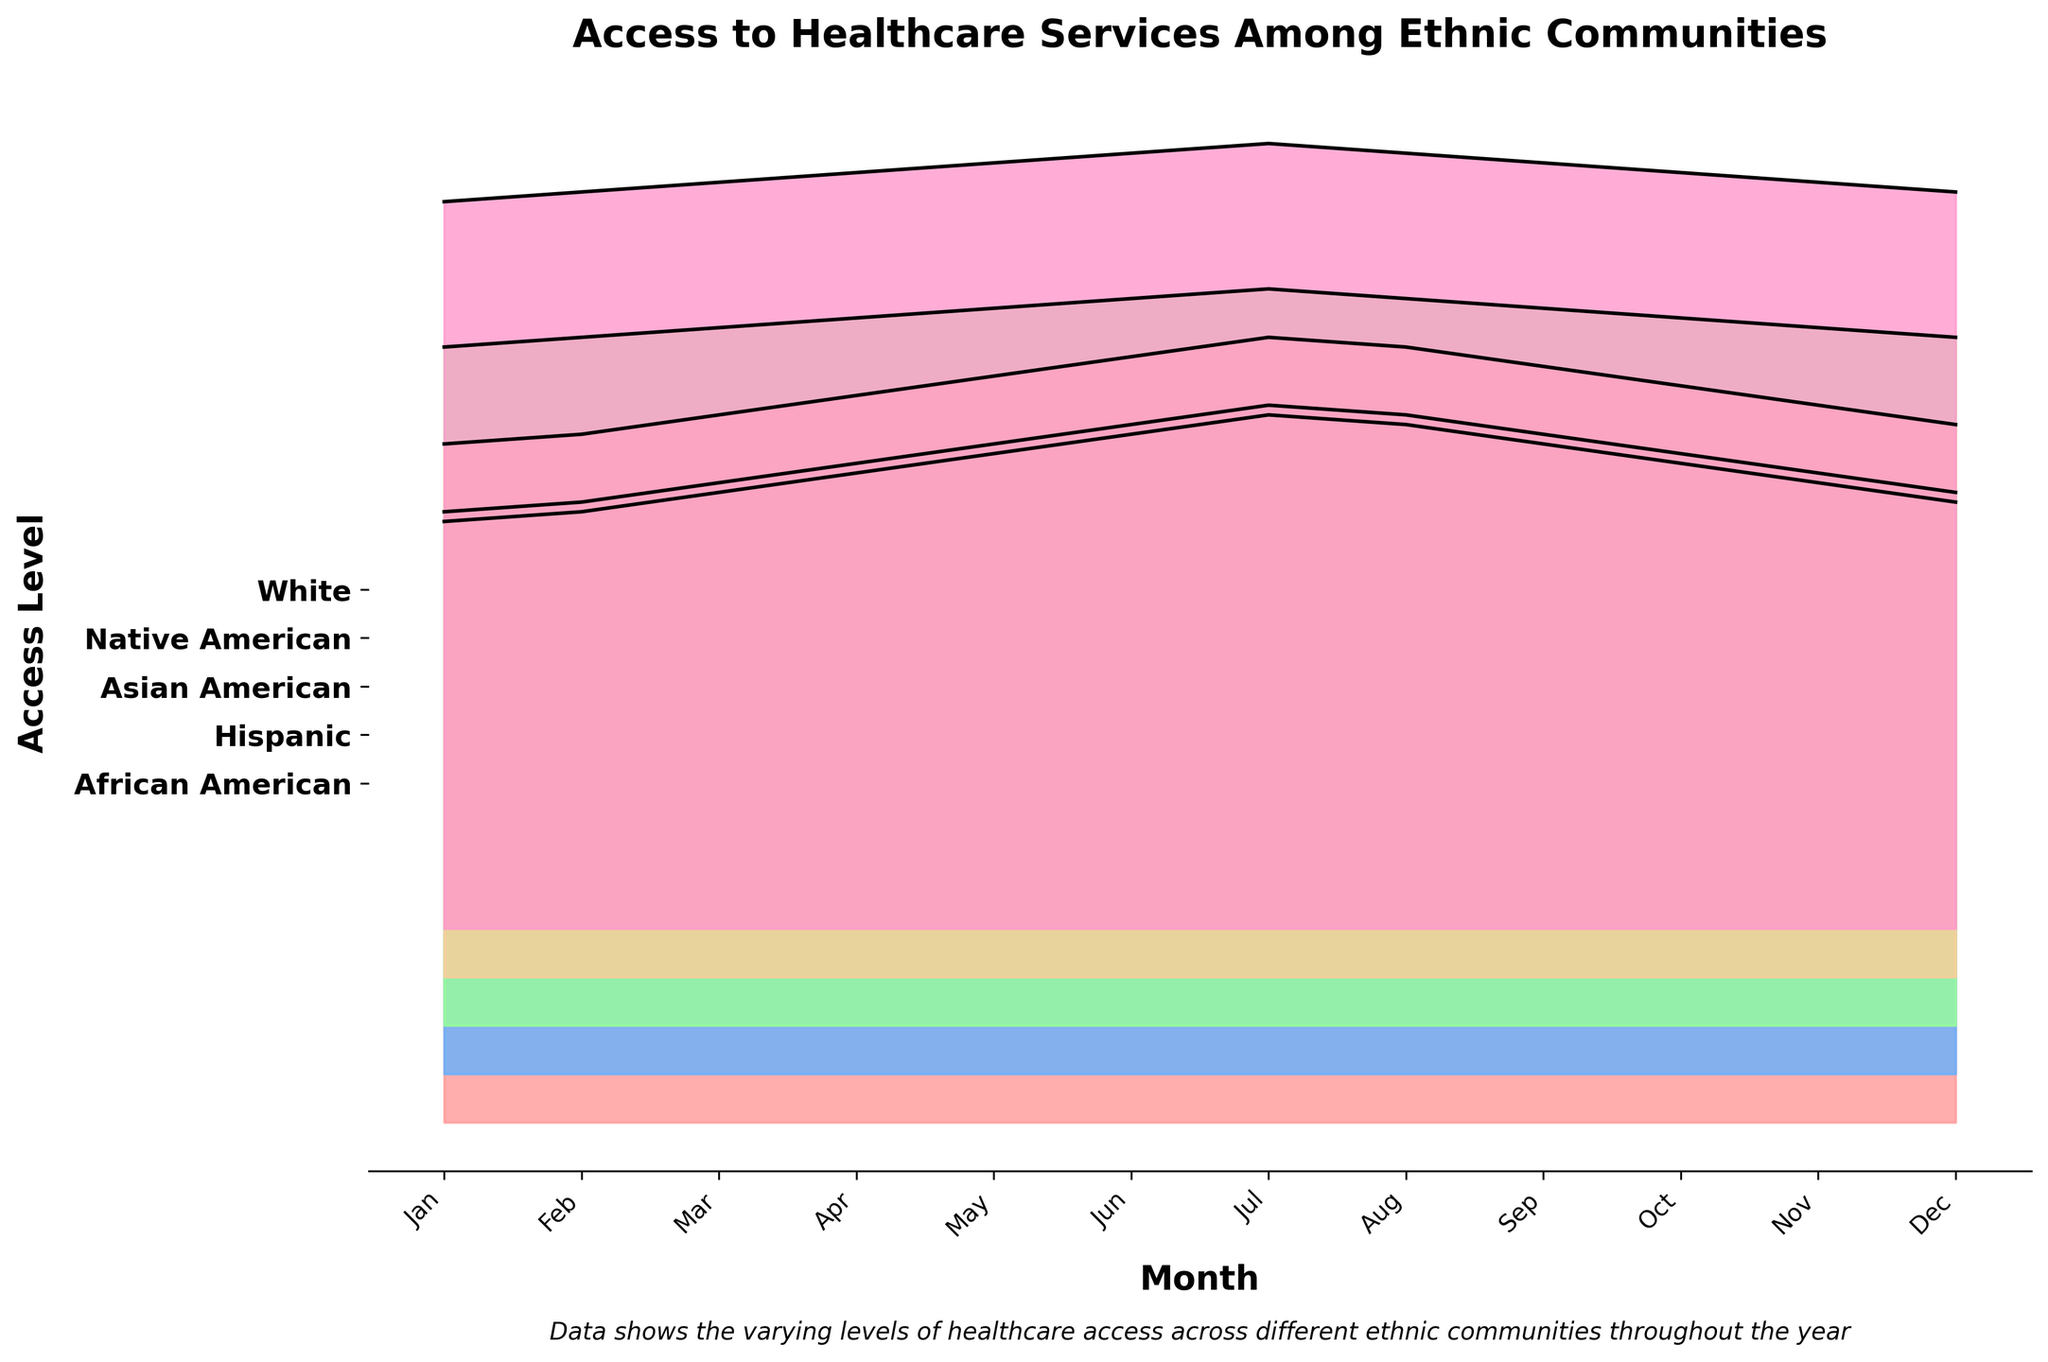What is the title of the chart? The title of the chart is usually displayed prominently at the top. In this case, the title is "Access to Healthcare Services Among Ethnic Communities".
Answer: Access to Healthcare Services Among Ethnic Communities Which ethnic community had the highest access level in January? We need to look at the January data points for each ethnic community and see which one is the highest. For January, White had the highest access level (75).
Answer: White How does healthcare access for African Americans change from January to December? We follow the African American data points from January (62) to December (64). The access level increases initially but then decreases towards the year's end, ending just above the starting point.
Answer: Starts at 62 in January, peaks around July, and ends at 64 in December Across the year, which month shows the peak access level for Hispanic people? By examining the data for Hispanic people month by month, the highest value is in July (69).
Answer: July Compare healthcare access in July for Asian Americans and Native Americans. In July, the access level for Asian Americans is 76, while it is 66 for Native Americans. Asian Americans have higher access in July.
Answer: Asian Americans have higher access Which two ethnic communities had the closest access levels in October? We look at the October data points: African American (68), Hispanic (64), Asian American (73), Native American (61), and White (78). Hispanic and Native American have the smallest difference (64 - 61 = 3).
Answer: Hispanic and Native American During which month did African Americans see the largest increase in access compared to the previous month? We calculate the differences between consecutive months for African Americans. The largest increase happened from June to July (73 - 71 = 2).
Answer: July Find the average access level for White people across the whole year. We sum up the monthly values for White (75+76+77+78+79+80+81+80+79+78+77+76 = 936) and divide by 12 (936/12).
Answer: 78 How does the access level of Native Americans in October compare to their access level in April? According to the data, Native American access in April is 60 and in October is 61. The access level is slightly higher in October compared to April (61 - 60 = 1).
Answer: Slightly higher in October What is the range of access levels for Asian Americans throughout the year? The minimum value for Asian Americans is taken from January (70) and the maximum from July (76). Therefore, the range is 76 - 70.
Answer: 6 